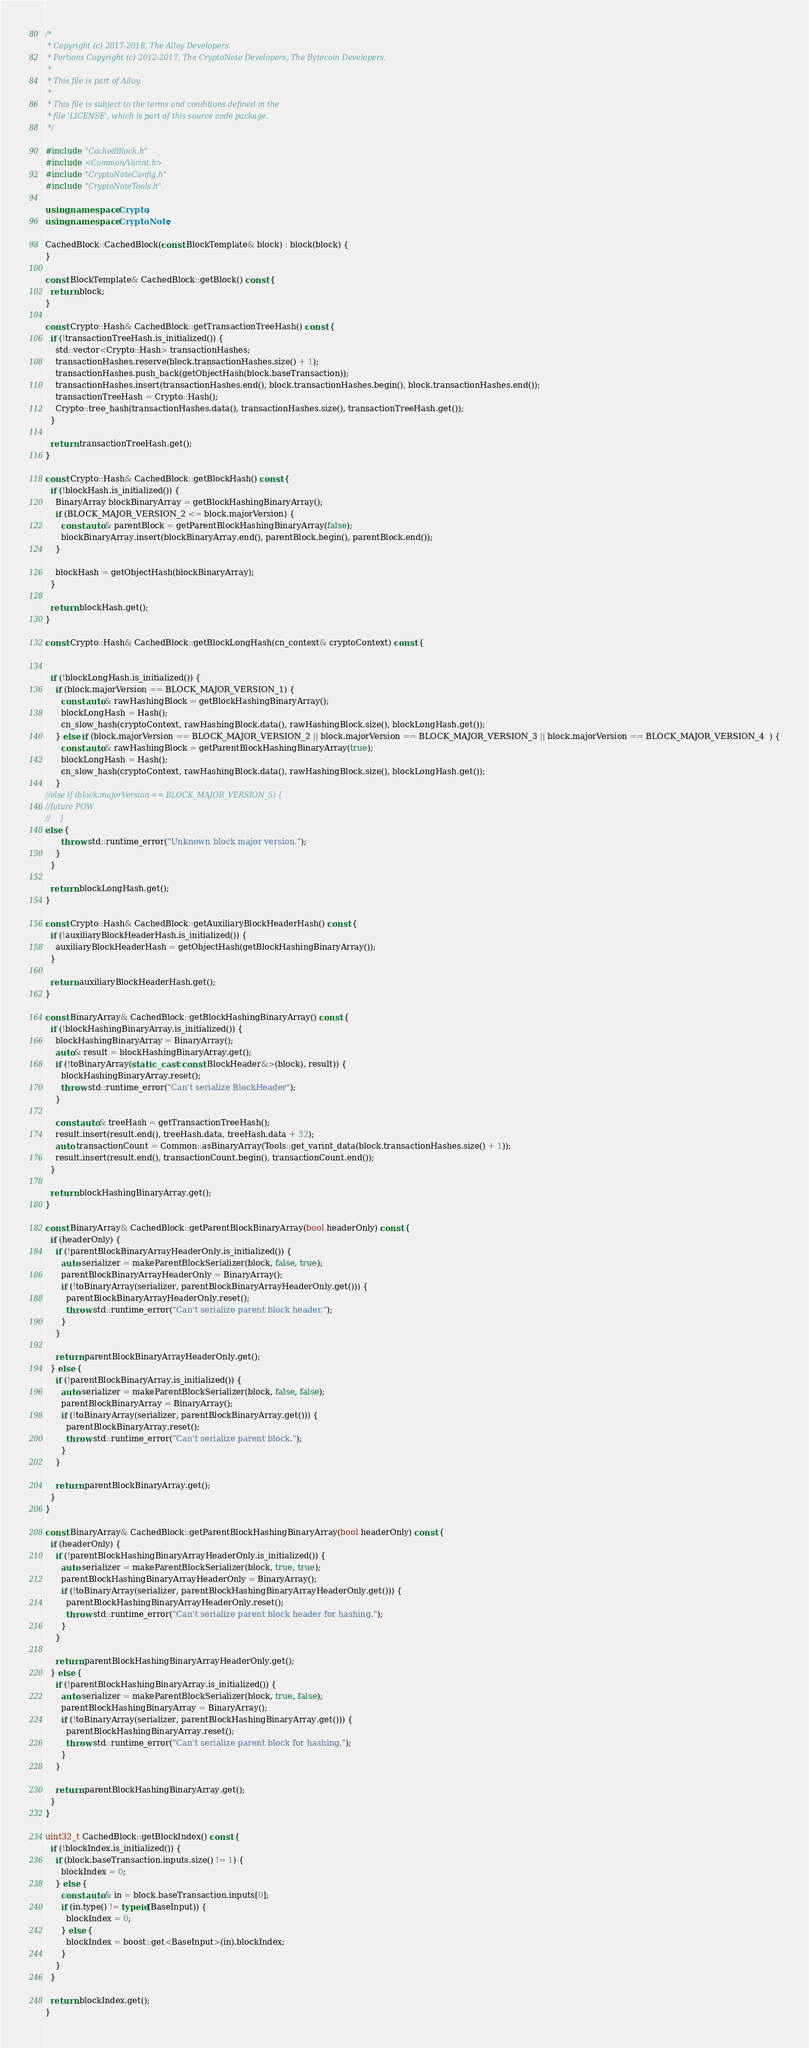<code> <loc_0><loc_0><loc_500><loc_500><_C++_>/*
 * Copyright (c) 2017-2018, The Alloy Developers.
 * Portions Copyright (c) 2012-2017, The CryptoNote Developers, The Bytecoin Developers.
 *
 * This file is part of Alloy.
 *
 * This file is subject to the terms and conditions defined in the
 * file 'LICENSE', which is part of this source code package.
 */

#include "CachedBlock.h"
#include <Common/Varint.h>
#include "CryptoNoteConfig.h"
#include "CryptoNoteTools.h"

using namespace Crypto;
using namespace CryptoNote;

CachedBlock::CachedBlock(const BlockTemplate& block) : block(block) {
}

const BlockTemplate& CachedBlock::getBlock() const {
  return block;
}

const Crypto::Hash& CachedBlock::getTransactionTreeHash() const {
  if (!transactionTreeHash.is_initialized()) {
    std::vector<Crypto::Hash> transactionHashes;
    transactionHashes.reserve(block.transactionHashes.size() + 1);
    transactionHashes.push_back(getObjectHash(block.baseTransaction));
    transactionHashes.insert(transactionHashes.end(), block.transactionHashes.begin(), block.transactionHashes.end());
    transactionTreeHash = Crypto::Hash();
    Crypto::tree_hash(transactionHashes.data(), transactionHashes.size(), transactionTreeHash.get());
  }

  return transactionTreeHash.get();
}

const Crypto::Hash& CachedBlock::getBlockHash() const {
  if (!blockHash.is_initialized()) {
    BinaryArray blockBinaryArray = getBlockHashingBinaryArray();
    if (BLOCK_MAJOR_VERSION_2 <= block.majorVersion) {
      const auto& parentBlock = getParentBlockHashingBinaryArray(false);
      blockBinaryArray.insert(blockBinaryArray.end(), parentBlock.begin(), parentBlock.end());
    }

    blockHash = getObjectHash(blockBinaryArray);
  }

  return blockHash.get();
}

const Crypto::Hash& CachedBlock::getBlockLongHash(cn_context& cryptoContext) const {


  if (!blockLongHash.is_initialized()) {
    if (block.majorVersion == BLOCK_MAJOR_VERSION_1) {
      const auto& rawHashingBlock = getBlockHashingBinaryArray();
      blockLongHash = Hash();
      cn_slow_hash(cryptoContext, rawHashingBlock.data(), rawHashingBlock.size(), blockLongHash.get());
    } else if (block.majorVersion == BLOCK_MAJOR_VERSION_2 || block.majorVersion == BLOCK_MAJOR_VERSION_3 || block.majorVersion == BLOCK_MAJOR_VERSION_4  ) {
      const auto& rawHashingBlock = getParentBlockHashingBinaryArray(true);
      blockLongHash = Hash();
      cn_slow_hash(cryptoContext, rawHashingBlock.data(), rawHashingBlock.size(), blockLongHash.get());
    } 
//else if (block.majorVersion == BLOCK_MAJOR_VERSION_5) {
//future POW
//    }
else {
      throw std::runtime_error("Unknown block major version.");
    }
  }

  return blockLongHash.get();
}

const Crypto::Hash& CachedBlock::getAuxiliaryBlockHeaderHash() const {
  if (!auxiliaryBlockHeaderHash.is_initialized()) {
    auxiliaryBlockHeaderHash = getObjectHash(getBlockHashingBinaryArray());
  }

  return auxiliaryBlockHeaderHash.get();
}

const BinaryArray& CachedBlock::getBlockHashingBinaryArray() const {
  if (!blockHashingBinaryArray.is_initialized()) {
    blockHashingBinaryArray = BinaryArray();
    auto& result = blockHashingBinaryArray.get();
    if (!toBinaryArray(static_cast<const BlockHeader&>(block), result)) {
      blockHashingBinaryArray.reset();
      throw std::runtime_error("Can't serialize BlockHeader");
    }

    const auto& treeHash = getTransactionTreeHash();
    result.insert(result.end(), treeHash.data, treeHash.data + 32);
    auto transactionCount = Common::asBinaryArray(Tools::get_varint_data(block.transactionHashes.size() + 1));
    result.insert(result.end(), transactionCount.begin(), transactionCount.end());
  }

  return blockHashingBinaryArray.get();
}

const BinaryArray& CachedBlock::getParentBlockBinaryArray(bool headerOnly) const {
  if (headerOnly) {
    if (!parentBlockBinaryArrayHeaderOnly.is_initialized()) {
      auto serializer = makeParentBlockSerializer(block, false, true);
      parentBlockBinaryArrayHeaderOnly = BinaryArray();
      if (!toBinaryArray(serializer, parentBlockBinaryArrayHeaderOnly.get())) {
        parentBlockBinaryArrayHeaderOnly.reset();
        throw std::runtime_error("Can't serialize parent block header.");
      }
    }

    return parentBlockBinaryArrayHeaderOnly.get();
  } else {
    if (!parentBlockBinaryArray.is_initialized()) {
      auto serializer = makeParentBlockSerializer(block, false, false);
      parentBlockBinaryArray = BinaryArray();
      if (!toBinaryArray(serializer, parentBlockBinaryArray.get())) {
        parentBlockBinaryArray.reset();
        throw std::runtime_error("Can't serialize parent block.");
      }
    }

    return parentBlockBinaryArray.get();
  }
}

const BinaryArray& CachedBlock::getParentBlockHashingBinaryArray(bool headerOnly) const {
  if (headerOnly) {
    if (!parentBlockHashingBinaryArrayHeaderOnly.is_initialized()) {
      auto serializer = makeParentBlockSerializer(block, true, true);
      parentBlockHashingBinaryArrayHeaderOnly = BinaryArray();
      if (!toBinaryArray(serializer, parentBlockHashingBinaryArrayHeaderOnly.get())) {
        parentBlockHashingBinaryArrayHeaderOnly.reset();
        throw std::runtime_error("Can't serialize parent block header for hashing.");
      }
    }

    return parentBlockHashingBinaryArrayHeaderOnly.get();
  } else {
    if (!parentBlockHashingBinaryArray.is_initialized()) {
      auto serializer = makeParentBlockSerializer(block, true, false);
      parentBlockHashingBinaryArray = BinaryArray();
      if (!toBinaryArray(serializer, parentBlockHashingBinaryArray.get())) {
        parentBlockHashingBinaryArray.reset();
        throw std::runtime_error("Can't serialize parent block for hashing.");
      }
    }

    return parentBlockHashingBinaryArray.get();
  }
}

uint32_t CachedBlock::getBlockIndex() const {
  if (!blockIndex.is_initialized()) {
    if (block.baseTransaction.inputs.size() != 1) {
      blockIndex = 0;
    } else {
      const auto& in = block.baseTransaction.inputs[0];
      if (in.type() != typeid(BaseInput)) {
        blockIndex = 0;
      } else {
        blockIndex = boost::get<BaseInput>(in).blockIndex;
      }
    }
  }

  return blockIndex.get();
}
</code> 